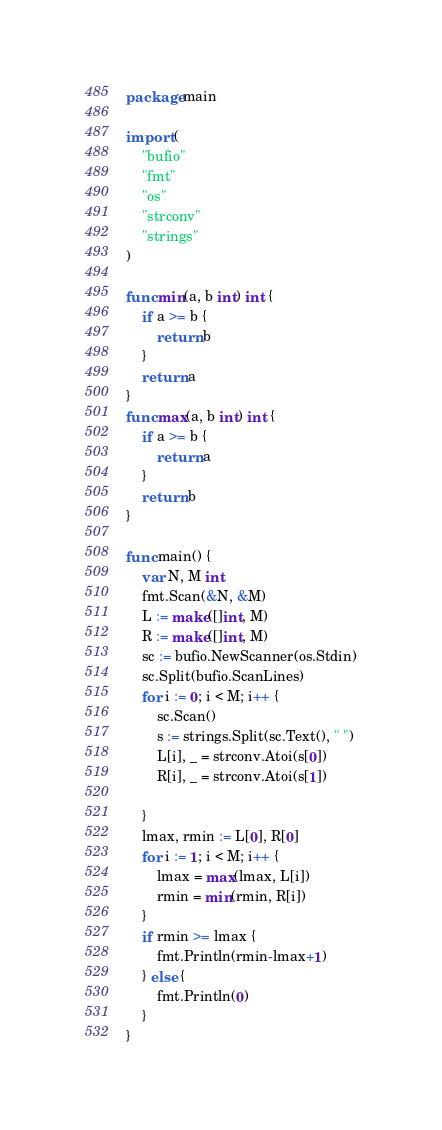Convert code to text. <code><loc_0><loc_0><loc_500><loc_500><_Go_>package main

import (
	"bufio"
	"fmt"
	"os"
	"strconv"
	"strings"
)

func min(a, b int) int {
	if a >= b {
		return b
	}
	return a
}
func max(a, b int) int {
	if a >= b {
		return a
	}
	return b
}

func main() {
	var N, M int
	fmt.Scan(&N, &M)
	L := make([]int, M)
	R := make([]int, M)
	sc := bufio.NewScanner(os.Stdin)
	sc.Split(bufio.ScanLines)
	for i := 0; i < M; i++ {
		sc.Scan()
		s := strings.Split(sc.Text(), " ")
		L[i], _ = strconv.Atoi(s[0])
		R[i], _ = strconv.Atoi(s[1])

	}
	lmax, rmin := L[0], R[0]
	for i := 1; i < M; i++ {
		lmax = max(lmax, L[i])
		rmin = min(rmin, R[i])
	}
	if rmin >= lmax {
		fmt.Println(rmin-lmax+1)
	} else {
		fmt.Println(0)
	}
}
</code> 